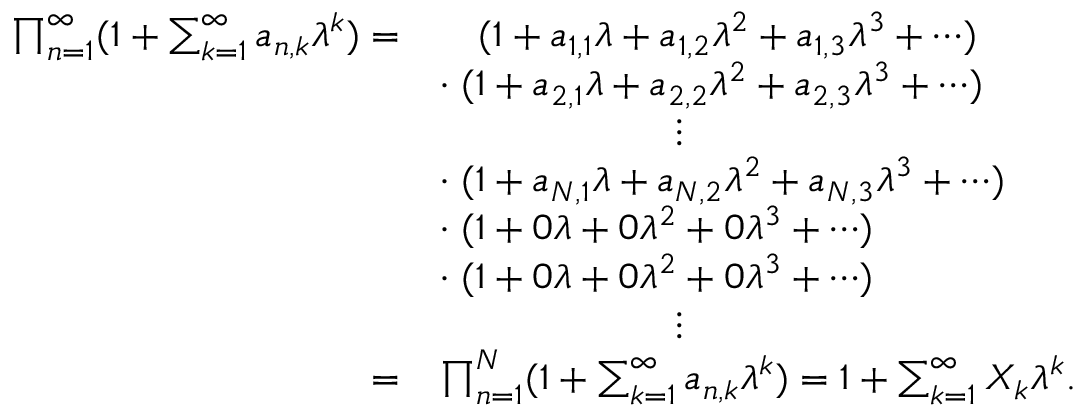Convert formula to latex. <formula><loc_0><loc_0><loc_500><loc_500>\begin{array} { r l } { \prod _ { n = 1 } ^ { \infty } ( 1 + \sum _ { k = 1 } ^ { \infty } a _ { n , k } \lambda ^ { k } ) = } & { \quad ( 1 + a _ { 1 , 1 } \lambda + a _ { 1 , 2 } \lambda ^ { 2 } + a _ { 1 , 3 } \lambda ^ { 3 } + \cdots ) } \\ & { \cdot \, ( 1 + a _ { 2 , 1 } \lambda + a _ { 2 , 2 } \lambda ^ { 2 } + a _ { 2 , 3 } \lambda ^ { 3 } + \cdots ) } \\ & { \quad \vdots } \\ & { \cdot \, ( 1 + a _ { N , 1 } \lambda + a _ { N , 2 } \lambda ^ { 2 } + a _ { N , 3 } \lambda ^ { 3 } + \cdots ) } \\ & { \cdot \, ( 1 + 0 \lambda + 0 \lambda ^ { 2 } + 0 \lambda ^ { 3 } + \cdots ) } \\ & { \cdot \, ( 1 + 0 \lambda + 0 \lambda ^ { 2 } + 0 \lambda ^ { 3 } + \cdots ) } \\ & { \quad \vdots } \\ { = } & { \prod _ { n = 1 } ^ { N } ( 1 + \sum _ { k = 1 } ^ { \infty } a _ { n , k } \lambda ^ { k } ) = 1 + \sum _ { k = 1 } ^ { \infty } X _ { k } \lambda ^ { k } . } \end{array}</formula> 